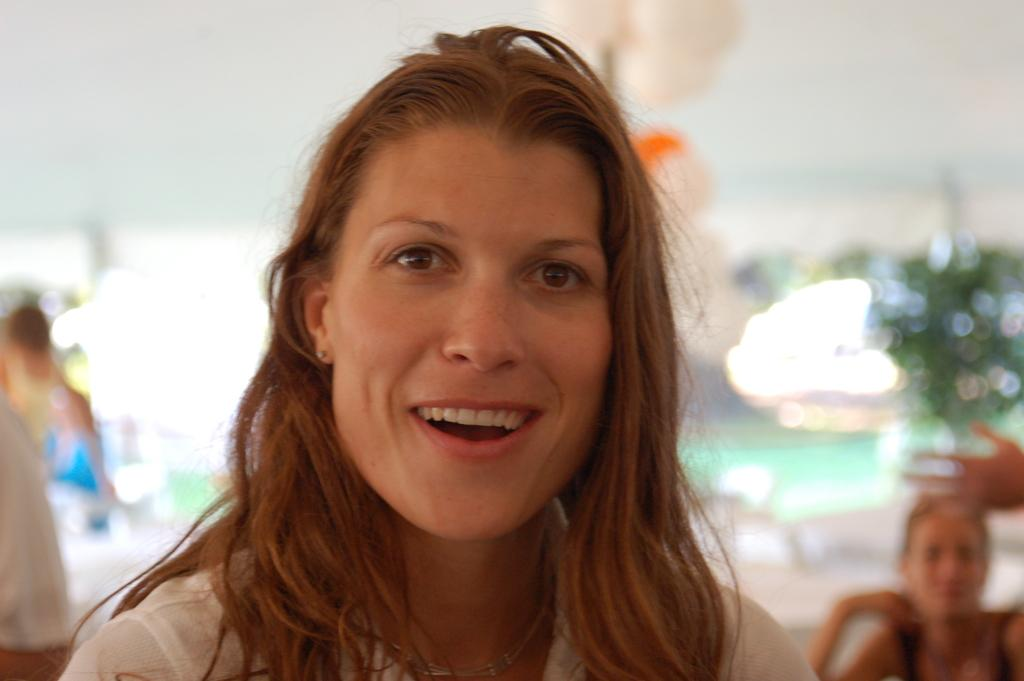Who is the main subject in the image? There is a woman in the image. What is the woman doing in the image? The woman is watching and smiling. Can you describe the background of the image? The background of the image has a blurred view. Are there any other people visible in the image? Yes, there are people visible in the image. What type of cord is being used to shake the woman's hand in the image? There is no cord present in the image, nor is anyone shaking the woman's hand. 